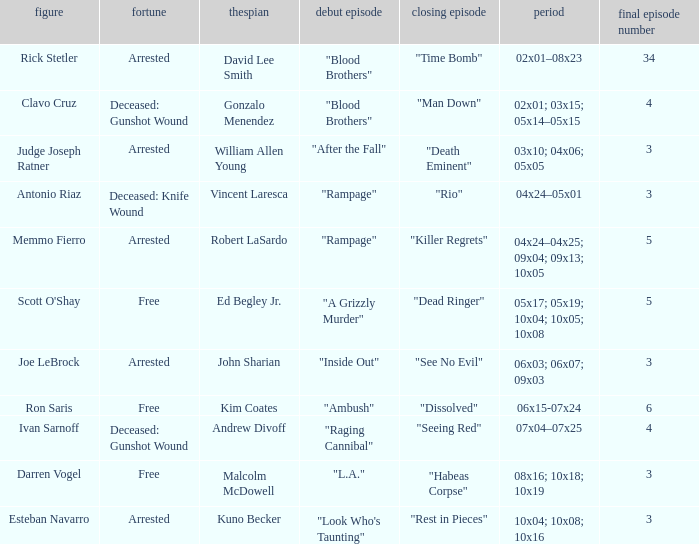What's the total number of final epbeingode count with character being rick stetler 1.0. 